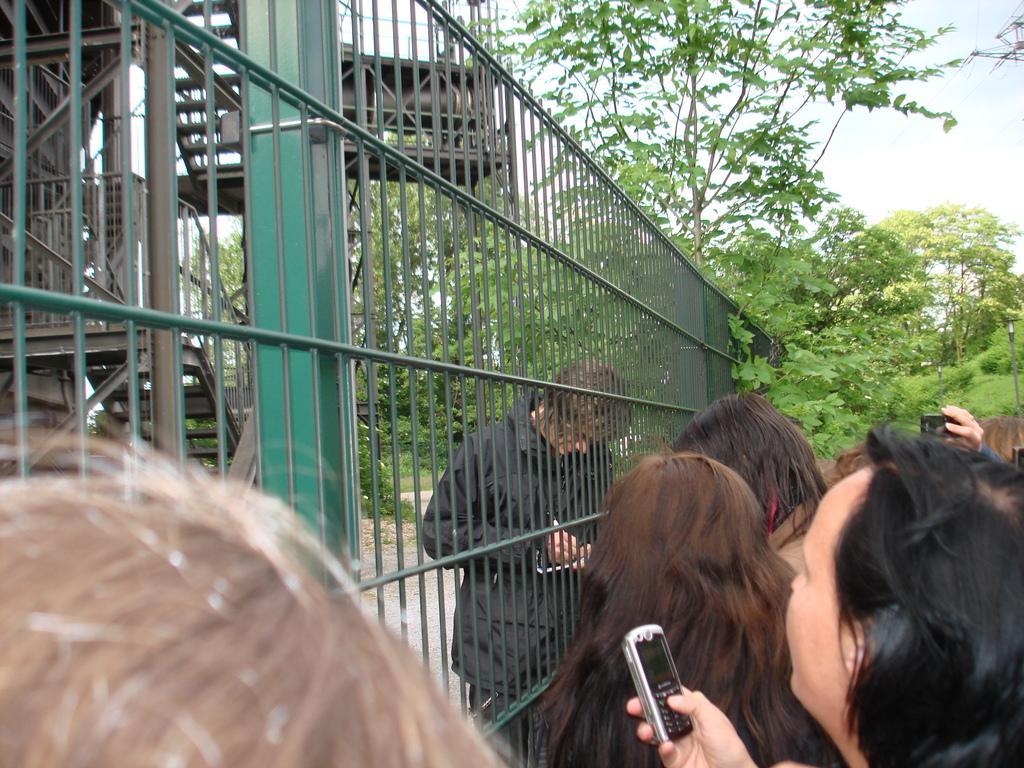Please provide a concise description of this image. In this image, In the bottom there are some people standing and in the left side there is a fence which is in green color, In the background there are some plants and trees which are in green color. 